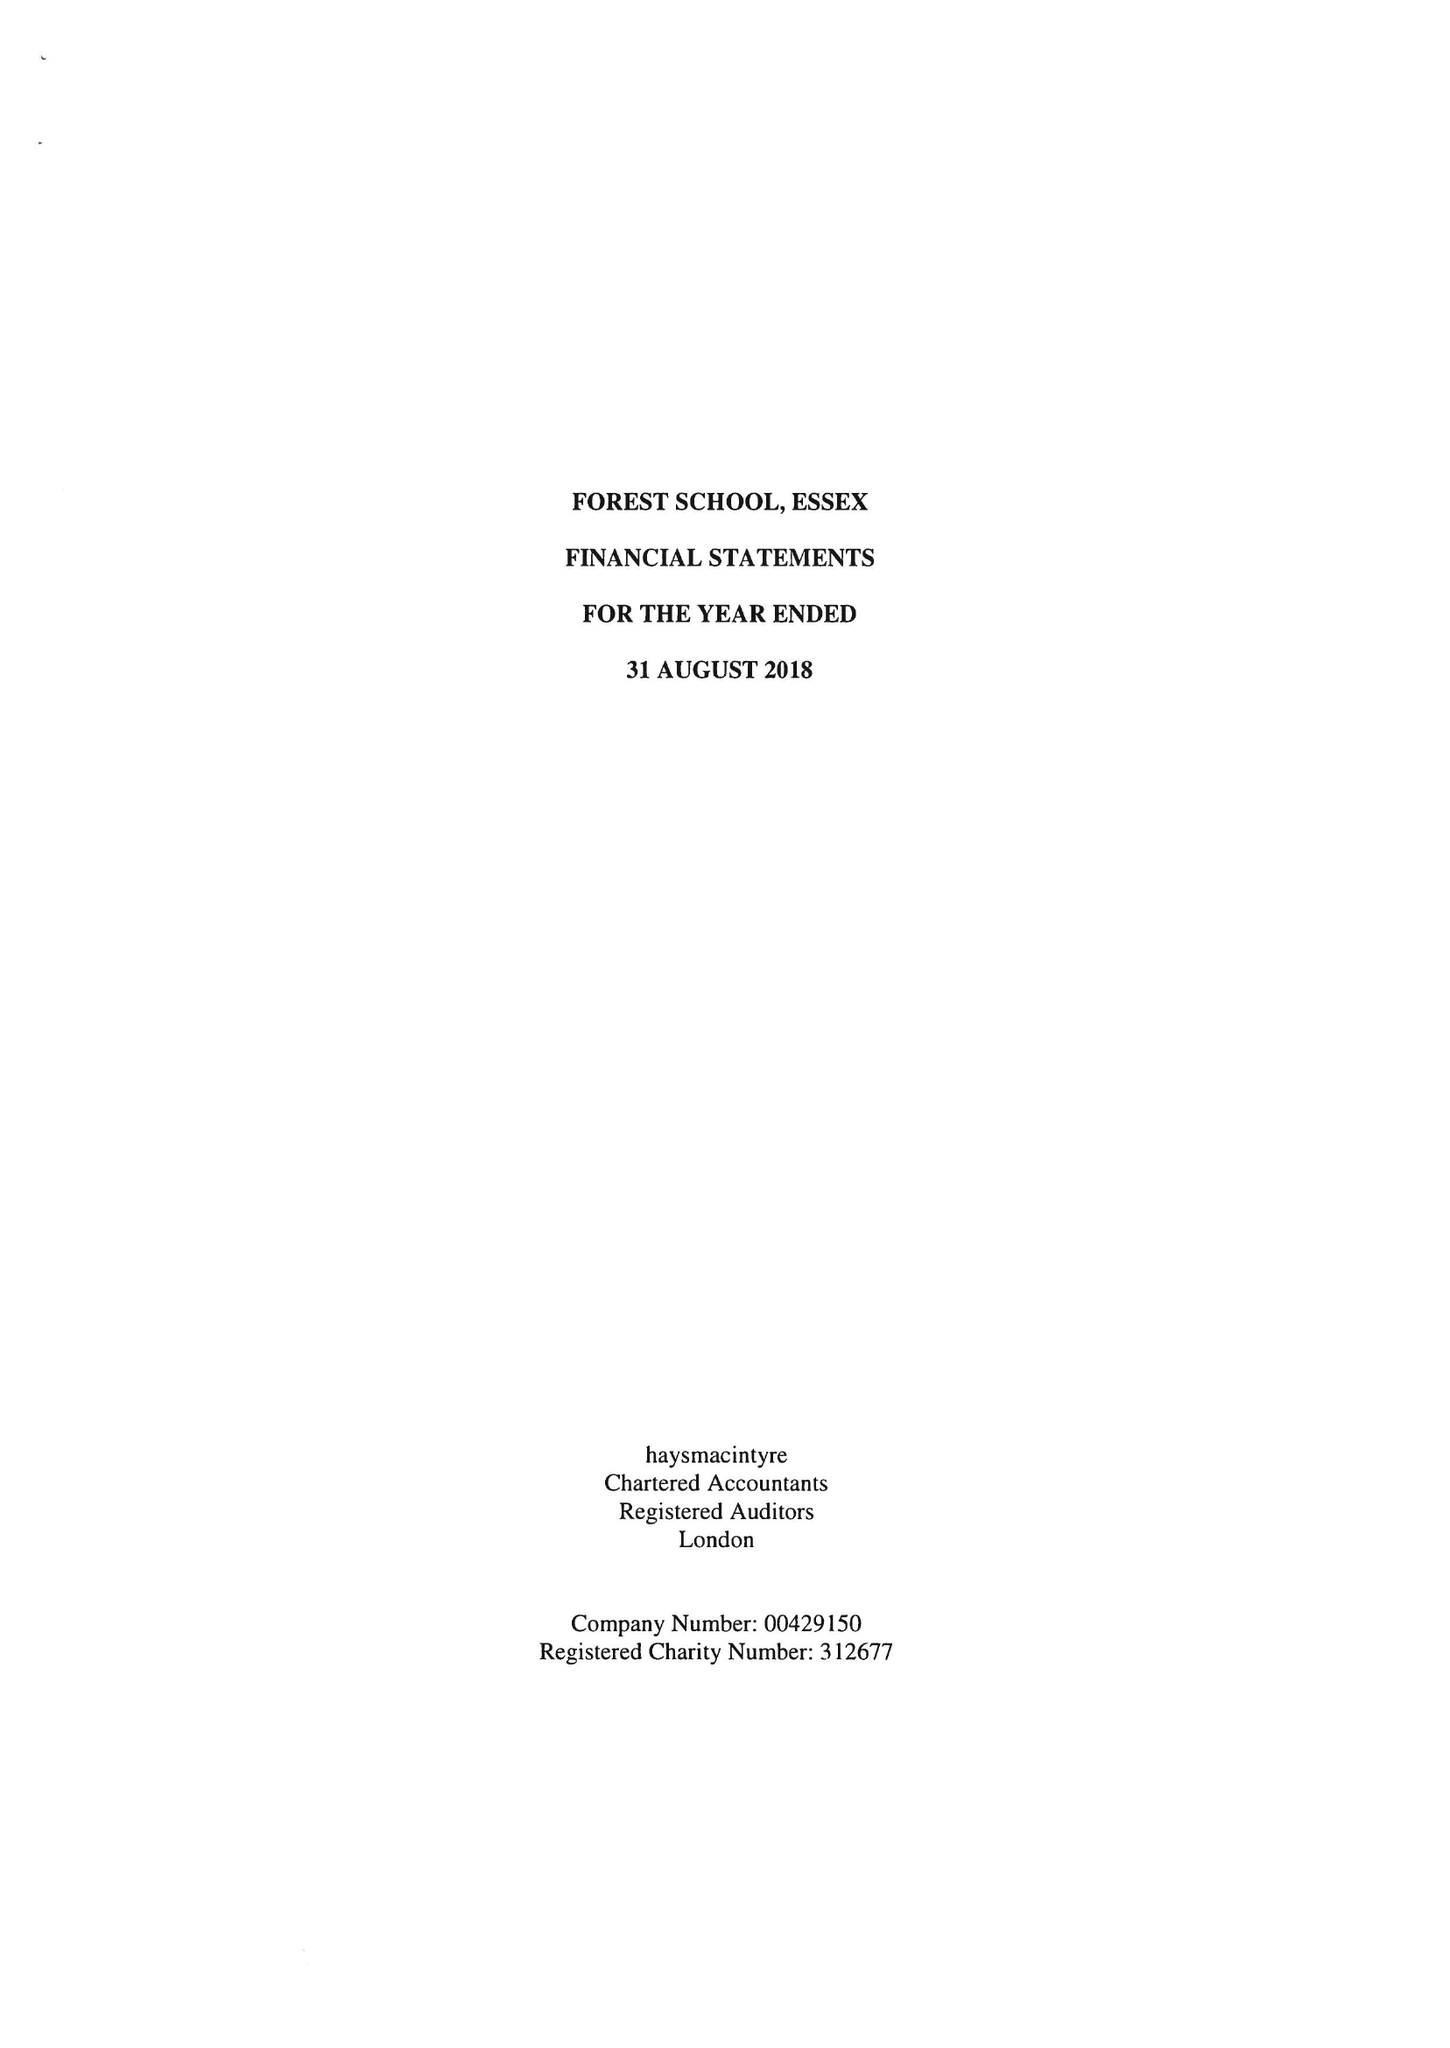What is the value for the report_date?
Answer the question using a single word or phrase. 2018-08-31 